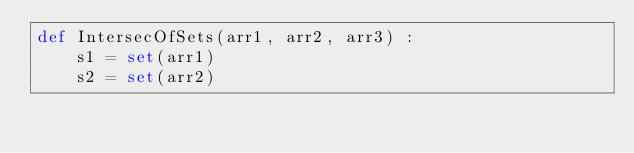Convert code to text. <code><loc_0><loc_0><loc_500><loc_500><_Python_>def IntersecOfSets(arr1, arr2, arr3) :
    s1 = set(arr1)
    s2 = set(arr2)</code> 